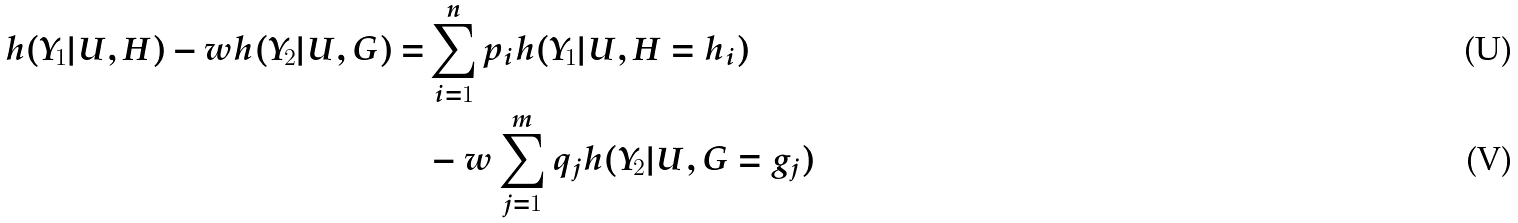<formula> <loc_0><loc_0><loc_500><loc_500>h ( Y _ { 1 } | U , H ) - w h ( Y _ { 2 } | U , G ) = & \sum _ { i = 1 } ^ { n } p _ { i } h ( Y _ { 1 } | U , H = h _ { i } ) \\ & - w \sum _ { j = 1 } ^ { m } q _ { j } h ( Y _ { 2 } | U , G = g _ { j } )</formula> 